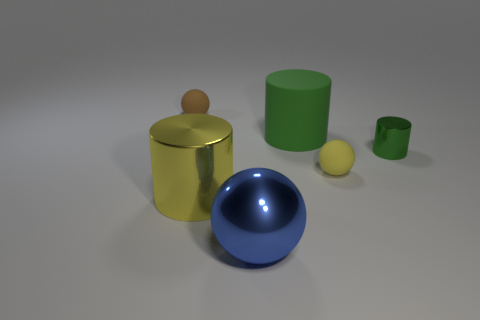What size is the green matte cylinder?
Make the answer very short. Large. How big is the sphere that is both on the right side of the brown ball and left of the yellow matte thing?
Provide a short and direct response. Large. There is a small matte object that is behind the green shiny thing; what shape is it?
Provide a succinct answer. Sphere. Is the material of the blue object the same as the thing that is behind the rubber cylinder?
Give a very brief answer. No. Do the blue object and the small yellow thing have the same shape?
Your answer should be very brief. Yes. What is the material of the tiny brown object that is the same shape as the tiny yellow object?
Provide a short and direct response. Rubber. There is a metallic object that is both right of the yellow cylinder and left of the small yellow rubber ball; what color is it?
Your answer should be very brief. Blue. The small metal object has what color?
Offer a terse response. Green. There is a tiny thing that is the same color as the rubber cylinder; what is its material?
Your answer should be compact. Metal. Are there any yellow things of the same shape as the small brown object?
Provide a short and direct response. Yes. 